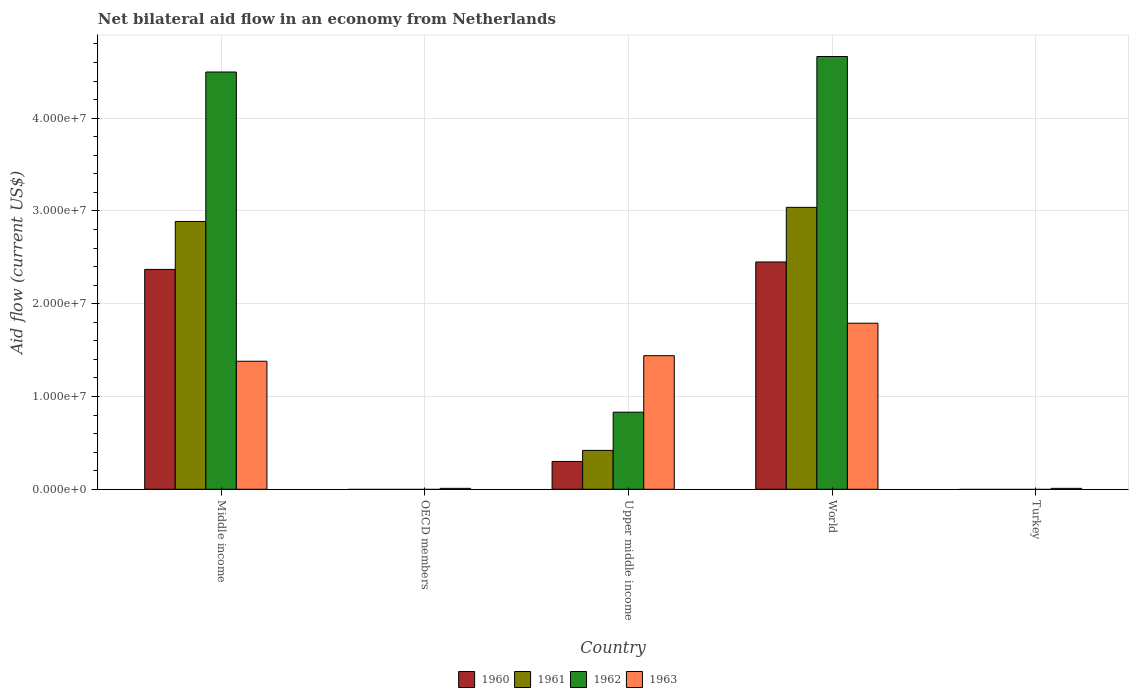How many bars are there on the 3rd tick from the right?
Provide a succinct answer. 4. In how many cases, is the number of bars for a given country not equal to the number of legend labels?
Keep it short and to the point. 2. What is the net bilateral aid flow in 1962 in Upper middle income?
Give a very brief answer. 8.31e+06. Across all countries, what is the maximum net bilateral aid flow in 1963?
Your response must be concise. 1.79e+07. Across all countries, what is the minimum net bilateral aid flow in 1962?
Offer a terse response. 0. What is the total net bilateral aid flow in 1963 in the graph?
Give a very brief answer. 4.63e+07. What is the difference between the net bilateral aid flow in 1961 in Upper middle income and that in World?
Provide a short and direct response. -2.62e+07. What is the difference between the net bilateral aid flow in 1963 in World and the net bilateral aid flow in 1962 in Turkey?
Provide a succinct answer. 1.79e+07. What is the average net bilateral aid flow in 1961 per country?
Keep it short and to the point. 1.27e+07. What is the difference between the net bilateral aid flow of/in 1963 and net bilateral aid flow of/in 1962 in World?
Make the answer very short. -2.88e+07. What is the ratio of the net bilateral aid flow in 1963 in Middle income to that in Upper middle income?
Ensure brevity in your answer.  0.96. What is the difference between the highest and the second highest net bilateral aid flow in 1963?
Give a very brief answer. 3.50e+06. What is the difference between the highest and the lowest net bilateral aid flow in 1960?
Keep it short and to the point. 2.45e+07. In how many countries, is the net bilateral aid flow in 1962 greater than the average net bilateral aid flow in 1962 taken over all countries?
Keep it short and to the point. 2. Is it the case that in every country, the sum of the net bilateral aid flow in 1962 and net bilateral aid flow in 1961 is greater than the net bilateral aid flow in 1963?
Your answer should be compact. No. Are all the bars in the graph horizontal?
Ensure brevity in your answer.  No. What is the title of the graph?
Give a very brief answer. Net bilateral aid flow in an economy from Netherlands. What is the label or title of the X-axis?
Your response must be concise. Country. What is the Aid flow (current US$) of 1960 in Middle income?
Provide a short and direct response. 2.37e+07. What is the Aid flow (current US$) in 1961 in Middle income?
Make the answer very short. 2.89e+07. What is the Aid flow (current US$) in 1962 in Middle income?
Offer a terse response. 4.50e+07. What is the Aid flow (current US$) of 1963 in Middle income?
Ensure brevity in your answer.  1.38e+07. What is the Aid flow (current US$) in 1960 in OECD members?
Your answer should be compact. 0. What is the Aid flow (current US$) of 1961 in OECD members?
Give a very brief answer. 0. What is the Aid flow (current US$) in 1961 in Upper middle income?
Give a very brief answer. 4.19e+06. What is the Aid flow (current US$) in 1962 in Upper middle income?
Provide a short and direct response. 8.31e+06. What is the Aid flow (current US$) of 1963 in Upper middle income?
Offer a very short reply. 1.44e+07. What is the Aid flow (current US$) of 1960 in World?
Give a very brief answer. 2.45e+07. What is the Aid flow (current US$) of 1961 in World?
Ensure brevity in your answer.  3.04e+07. What is the Aid flow (current US$) in 1962 in World?
Make the answer very short. 4.66e+07. What is the Aid flow (current US$) in 1963 in World?
Provide a succinct answer. 1.79e+07. What is the Aid flow (current US$) in 1961 in Turkey?
Your answer should be very brief. 0. What is the Aid flow (current US$) in 1963 in Turkey?
Provide a succinct answer. 1.00e+05. Across all countries, what is the maximum Aid flow (current US$) in 1960?
Provide a short and direct response. 2.45e+07. Across all countries, what is the maximum Aid flow (current US$) of 1961?
Keep it short and to the point. 3.04e+07. Across all countries, what is the maximum Aid flow (current US$) of 1962?
Ensure brevity in your answer.  4.66e+07. Across all countries, what is the maximum Aid flow (current US$) of 1963?
Provide a succinct answer. 1.79e+07. Across all countries, what is the minimum Aid flow (current US$) in 1960?
Your response must be concise. 0. Across all countries, what is the minimum Aid flow (current US$) in 1962?
Make the answer very short. 0. Across all countries, what is the minimum Aid flow (current US$) of 1963?
Offer a terse response. 1.00e+05. What is the total Aid flow (current US$) of 1960 in the graph?
Provide a short and direct response. 5.12e+07. What is the total Aid flow (current US$) of 1961 in the graph?
Your response must be concise. 6.34e+07. What is the total Aid flow (current US$) in 1962 in the graph?
Your answer should be very brief. 9.99e+07. What is the total Aid flow (current US$) of 1963 in the graph?
Provide a succinct answer. 4.63e+07. What is the difference between the Aid flow (current US$) of 1963 in Middle income and that in OECD members?
Give a very brief answer. 1.37e+07. What is the difference between the Aid flow (current US$) of 1960 in Middle income and that in Upper middle income?
Offer a very short reply. 2.07e+07. What is the difference between the Aid flow (current US$) in 1961 in Middle income and that in Upper middle income?
Your answer should be very brief. 2.47e+07. What is the difference between the Aid flow (current US$) of 1962 in Middle income and that in Upper middle income?
Give a very brief answer. 3.67e+07. What is the difference between the Aid flow (current US$) in 1963 in Middle income and that in Upper middle income?
Provide a succinct answer. -6.00e+05. What is the difference between the Aid flow (current US$) in 1960 in Middle income and that in World?
Ensure brevity in your answer.  -8.00e+05. What is the difference between the Aid flow (current US$) in 1961 in Middle income and that in World?
Your answer should be compact. -1.52e+06. What is the difference between the Aid flow (current US$) of 1962 in Middle income and that in World?
Your answer should be very brief. -1.67e+06. What is the difference between the Aid flow (current US$) in 1963 in Middle income and that in World?
Provide a short and direct response. -4.10e+06. What is the difference between the Aid flow (current US$) of 1963 in Middle income and that in Turkey?
Give a very brief answer. 1.37e+07. What is the difference between the Aid flow (current US$) in 1963 in OECD members and that in Upper middle income?
Your answer should be very brief. -1.43e+07. What is the difference between the Aid flow (current US$) in 1963 in OECD members and that in World?
Provide a succinct answer. -1.78e+07. What is the difference between the Aid flow (current US$) of 1960 in Upper middle income and that in World?
Give a very brief answer. -2.15e+07. What is the difference between the Aid flow (current US$) in 1961 in Upper middle income and that in World?
Offer a very short reply. -2.62e+07. What is the difference between the Aid flow (current US$) of 1962 in Upper middle income and that in World?
Offer a terse response. -3.83e+07. What is the difference between the Aid flow (current US$) of 1963 in Upper middle income and that in World?
Your answer should be very brief. -3.50e+06. What is the difference between the Aid flow (current US$) in 1963 in Upper middle income and that in Turkey?
Offer a very short reply. 1.43e+07. What is the difference between the Aid flow (current US$) in 1963 in World and that in Turkey?
Give a very brief answer. 1.78e+07. What is the difference between the Aid flow (current US$) in 1960 in Middle income and the Aid flow (current US$) in 1963 in OECD members?
Give a very brief answer. 2.36e+07. What is the difference between the Aid flow (current US$) in 1961 in Middle income and the Aid flow (current US$) in 1963 in OECD members?
Make the answer very short. 2.88e+07. What is the difference between the Aid flow (current US$) in 1962 in Middle income and the Aid flow (current US$) in 1963 in OECD members?
Your answer should be very brief. 4.49e+07. What is the difference between the Aid flow (current US$) in 1960 in Middle income and the Aid flow (current US$) in 1961 in Upper middle income?
Your answer should be compact. 1.95e+07. What is the difference between the Aid flow (current US$) of 1960 in Middle income and the Aid flow (current US$) of 1962 in Upper middle income?
Provide a succinct answer. 1.54e+07. What is the difference between the Aid flow (current US$) in 1960 in Middle income and the Aid flow (current US$) in 1963 in Upper middle income?
Offer a terse response. 9.30e+06. What is the difference between the Aid flow (current US$) in 1961 in Middle income and the Aid flow (current US$) in 1962 in Upper middle income?
Your response must be concise. 2.06e+07. What is the difference between the Aid flow (current US$) of 1961 in Middle income and the Aid flow (current US$) of 1963 in Upper middle income?
Provide a short and direct response. 1.45e+07. What is the difference between the Aid flow (current US$) of 1962 in Middle income and the Aid flow (current US$) of 1963 in Upper middle income?
Keep it short and to the point. 3.06e+07. What is the difference between the Aid flow (current US$) of 1960 in Middle income and the Aid flow (current US$) of 1961 in World?
Your answer should be very brief. -6.69e+06. What is the difference between the Aid flow (current US$) of 1960 in Middle income and the Aid flow (current US$) of 1962 in World?
Provide a succinct answer. -2.30e+07. What is the difference between the Aid flow (current US$) of 1960 in Middle income and the Aid flow (current US$) of 1963 in World?
Offer a very short reply. 5.80e+06. What is the difference between the Aid flow (current US$) in 1961 in Middle income and the Aid flow (current US$) in 1962 in World?
Your answer should be compact. -1.78e+07. What is the difference between the Aid flow (current US$) of 1961 in Middle income and the Aid flow (current US$) of 1963 in World?
Offer a very short reply. 1.10e+07. What is the difference between the Aid flow (current US$) in 1962 in Middle income and the Aid flow (current US$) in 1963 in World?
Give a very brief answer. 2.71e+07. What is the difference between the Aid flow (current US$) in 1960 in Middle income and the Aid flow (current US$) in 1963 in Turkey?
Your answer should be very brief. 2.36e+07. What is the difference between the Aid flow (current US$) in 1961 in Middle income and the Aid flow (current US$) in 1963 in Turkey?
Your response must be concise. 2.88e+07. What is the difference between the Aid flow (current US$) in 1962 in Middle income and the Aid flow (current US$) in 1963 in Turkey?
Your answer should be compact. 4.49e+07. What is the difference between the Aid flow (current US$) in 1960 in Upper middle income and the Aid flow (current US$) in 1961 in World?
Your response must be concise. -2.74e+07. What is the difference between the Aid flow (current US$) in 1960 in Upper middle income and the Aid flow (current US$) in 1962 in World?
Give a very brief answer. -4.36e+07. What is the difference between the Aid flow (current US$) of 1960 in Upper middle income and the Aid flow (current US$) of 1963 in World?
Give a very brief answer. -1.49e+07. What is the difference between the Aid flow (current US$) of 1961 in Upper middle income and the Aid flow (current US$) of 1962 in World?
Your answer should be compact. -4.25e+07. What is the difference between the Aid flow (current US$) of 1961 in Upper middle income and the Aid flow (current US$) of 1963 in World?
Keep it short and to the point. -1.37e+07. What is the difference between the Aid flow (current US$) in 1962 in Upper middle income and the Aid flow (current US$) in 1963 in World?
Keep it short and to the point. -9.59e+06. What is the difference between the Aid flow (current US$) of 1960 in Upper middle income and the Aid flow (current US$) of 1963 in Turkey?
Offer a terse response. 2.90e+06. What is the difference between the Aid flow (current US$) of 1961 in Upper middle income and the Aid flow (current US$) of 1963 in Turkey?
Ensure brevity in your answer.  4.09e+06. What is the difference between the Aid flow (current US$) of 1962 in Upper middle income and the Aid flow (current US$) of 1963 in Turkey?
Provide a succinct answer. 8.21e+06. What is the difference between the Aid flow (current US$) in 1960 in World and the Aid flow (current US$) in 1963 in Turkey?
Your answer should be very brief. 2.44e+07. What is the difference between the Aid flow (current US$) in 1961 in World and the Aid flow (current US$) in 1963 in Turkey?
Offer a very short reply. 3.03e+07. What is the difference between the Aid flow (current US$) in 1962 in World and the Aid flow (current US$) in 1963 in Turkey?
Offer a very short reply. 4.66e+07. What is the average Aid flow (current US$) in 1960 per country?
Offer a terse response. 1.02e+07. What is the average Aid flow (current US$) in 1961 per country?
Ensure brevity in your answer.  1.27e+07. What is the average Aid flow (current US$) in 1962 per country?
Provide a short and direct response. 2.00e+07. What is the average Aid flow (current US$) of 1963 per country?
Offer a terse response. 9.26e+06. What is the difference between the Aid flow (current US$) in 1960 and Aid flow (current US$) in 1961 in Middle income?
Offer a very short reply. -5.17e+06. What is the difference between the Aid flow (current US$) in 1960 and Aid flow (current US$) in 1962 in Middle income?
Your answer should be compact. -2.13e+07. What is the difference between the Aid flow (current US$) of 1960 and Aid flow (current US$) of 1963 in Middle income?
Offer a very short reply. 9.90e+06. What is the difference between the Aid flow (current US$) in 1961 and Aid flow (current US$) in 1962 in Middle income?
Your response must be concise. -1.61e+07. What is the difference between the Aid flow (current US$) in 1961 and Aid flow (current US$) in 1963 in Middle income?
Provide a short and direct response. 1.51e+07. What is the difference between the Aid flow (current US$) of 1962 and Aid flow (current US$) of 1963 in Middle income?
Offer a terse response. 3.12e+07. What is the difference between the Aid flow (current US$) in 1960 and Aid flow (current US$) in 1961 in Upper middle income?
Offer a terse response. -1.19e+06. What is the difference between the Aid flow (current US$) in 1960 and Aid flow (current US$) in 1962 in Upper middle income?
Provide a short and direct response. -5.31e+06. What is the difference between the Aid flow (current US$) in 1960 and Aid flow (current US$) in 1963 in Upper middle income?
Give a very brief answer. -1.14e+07. What is the difference between the Aid flow (current US$) in 1961 and Aid flow (current US$) in 1962 in Upper middle income?
Make the answer very short. -4.12e+06. What is the difference between the Aid flow (current US$) of 1961 and Aid flow (current US$) of 1963 in Upper middle income?
Keep it short and to the point. -1.02e+07. What is the difference between the Aid flow (current US$) of 1962 and Aid flow (current US$) of 1963 in Upper middle income?
Provide a succinct answer. -6.09e+06. What is the difference between the Aid flow (current US$) of 1960 and Aid flow (current US$) of 1961 in World?
Your answer should be compact. -5.89e+06. What is the difference between the Aid flow (current US$) in 1960 and Aid flow (current US$) in 1962 in World?
Offer a very short reply. -2.22e+07. What is the difference between the Aid flow (current US$) of 1960 and Aid flow (current US$) of 1963 in World?
Give a very brief answer. 6.60e+06. What is the difference between the Aid flow (current US$) of 1961 and Aid flow (current US$) of 1962 in World?
Keep it short and to the point. -1.63e+07. What is the difference between the Aid flow (current US$) of 1961 and Aid flow (current US$) of 1963 in World?
Provide a succinct answer. 1.25e+07. What is the difference between the Aid flow (current US$) of 1962 and Aid flow (current US$) of 1963 in World?
Your response must be concise. 2.88e+07. What is the ratio of the Aid flow (current US$) in 1963 in Middle income to that in OECD members?
Your answer should be compact. 138. What is the ratio of the Aid flow (current US$) of 1961 in Middle income to that in Upper middle income?
Your answer should be very brief. 6.89. What is the ratio of the Aid flow (current US$) of 1962 in Middle income to that in Upper middle income?
Ensure brevity in your answer.  5.41. What is the ratio of the Aid flow (current US$) of 1960 in Middle income to that in World?
Offer a very short reply. 0.97. What is the ratio of the Aid flow (current US$) of 1962 in Middle income to that in World?
Make the answer very short. 0.96. What is the ratio of the Aid flow (current US$) of 1963 in Middle income to that in World?
Provide a succinct answer. 0.77. What is the ratio of the Aid flow (current US$) in 1963 in Middle income to that in Turkey?
Your answer should be very brief. 138. What is the ratio of the Aid flow (current US$) in 1963 in OECD members to that in Upper middle income?
Keep it short and to the point. 0.01. What is the ratio of the Aid flow (current US$) of 1963 in OECD members to that in World?
Your answer should be very brief. 0.01. What is the ratio of the Aid flow (current US$) of 1963 in OECD members to that in Turkey?
Provide a succinct answer. 1. What is the ratio of the Aid flow (current US$) of 1960 in Upper middle income to that in World?
Your answer should be very brief. 0.12. What is the ratio of the Aid flow (current US$) of 1961 in Upper middle income to that in World?
Your answer should be compact. 0.14. What is the ratio of the Aid flow (current US$) of 1962 in Upper middle income to that in World?
Your answer should be very brief. 0.18. What is the ratio of the Aid flow (current US$) of 1963 in Upper middle income to that in World?
Make the answer very short. 0.8. What is the ratio of the Aid flow (current US$) of 1963 in Upper middle income to that in Turkey?
Make the answer very short. 144. What is the ratio of the Aid flow (current US$) in 1963 in World to that in Turkey?
Your response must be concise. 179. What is the difference between the highest and the second highest Aid flow (current US$) of 1960?
Offer a very short reply. 8.00e+05. What is the difference between the highest and the second highest Aid flow (current US$) in 1961?
Keep it short and to the point. 1.52e+06. What is the difference between the highest and the second highest Aid flow (current US$) in 1962?
Offer a terse response. 1.67e+06. What is the difference between the highest and the second highest Aid flow (current US$) of 1963?
Your answer should be compact. 3.50e+06. What is the difference between the highest and the lowest Aid flow (current US$) of 1960?
Your answer should be very brief. 2.45e+07. What is the difference between the highest and the lowest Aid flow (current US$) in 1961?
Your answer should be very brief. 3.04e+07. What is the difference between the highest and the lowest Aid flow (current US$) of 1962?
Offer a very short reply. 4.66e+07. What is the difference between the highest and the lowest Aid flow (current US$) in 1963?
Provide a succinct answer. 1.78e+07. 